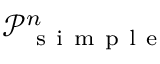Convert formula to latex. <formula><loc_0><loc_0><loc_500><loc_500>\mathcal { P } _ { s i m p l e } ^ { n }</formula> 